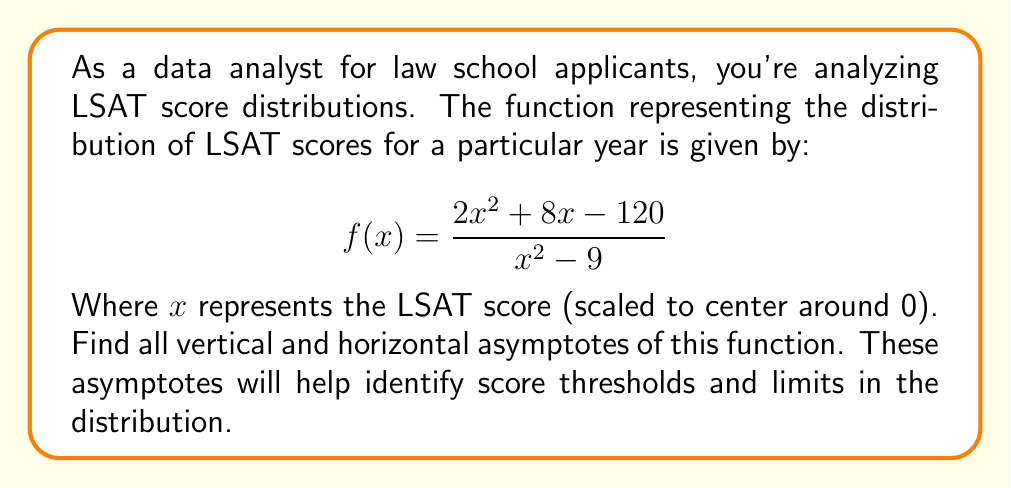Can you solve this math problem? To find the asymptotes, we'll follow these steps:

1) Vertical Asymptotes:
   Vertical asymptotes occur when the denominator equals zero.
   Solve $x^2 - 9 = 0$
   $(x+3)(x-3) = 0$
   $x = 3$ or $x = -3$

   So, there are vertical asymptotes at $x = 3$ and $x = -3$.

2) Horizontal Asymptote:
   To find the horizontal asymptote, compare the degrees of the numerator and denominator.
   
   Numerator degree: 2
   Denominator degree: 2
   
   When degrees are equal, the horizontal asymptote is the ratio of the leading coefficients:
   
   $$\lim_{x \to \infty} \frac{2x^2 + 8x - 120}{x^2 - 9} = \frac{2}{1} = 2$$

   So, there is a horizontal asymptote at $y = 2$.

3) Slant Asymptotes:
   Since the degree of the numerator equals the degree of the denominator, there is no slant asymptote.
Answer: Vertical asymptotes: $x = 3$ and $x = -3$; Horizontal asymptote: $y = 2$ 